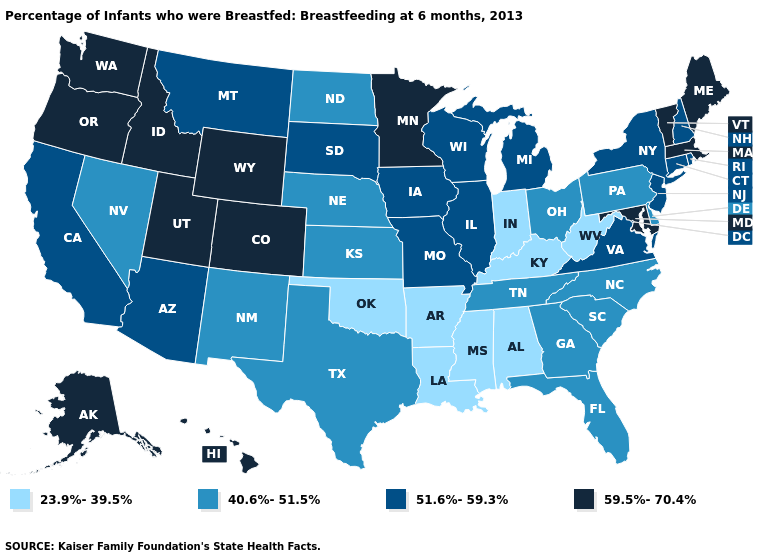What is the value of Mississippi?
Write a very short answer. 23.9%-39.5%. What is the highest value in states that border Tennessee?
Concise answer only. 51.6%-59.3%. What is the value of Alabama?
Answer briefly. 23.9%-39.5%. What is the highest value in the Northeast ?
Keep it brief. 59.5%-70.4%. Is the legend a continuous bar?
Be succinct. No. Does Illinois have the highest value in the USA?
Give a very brief answer. No. What is the highest value in states that border Wyoming?
Quick response, please. 59.5%-70.4%. What is the value of Delaware?
Give a very brief answer. 40.6%-51.5%. Which states have the lowest value in the USA?
Short answer required. Alabama, Arkansas, Indiana, Kentucky, Louisiana, Mississippi, Oklahoma, West Virginia. Name the states that have a value in the range 51.6%-59.3%?
Concise answer only. Arizona, California, Connecticut, Illinois, Iowa, Michigan, Missouri, Montana, New Hampshire, New Jersey, New York, Rhode Island, South Dakota, Virginia, Wisconsin. What is the highest value in the MidWest ?
Short answer required. 59.5%-70.4%. Does Alabama have a lower value than Hawaii?
Keep it brief. Yes. What is the highest value in the USA?
Concise answer only. 59.5%-70.4%. Name the states that have a value in the range 40.6%-51.5%?
Be succinct. Delaware, Florida, Georgia, Kansas, Nebraska, Nevada, New Mexico, North Carolina, North Dakota, Ohio, Pennsylvania, South Carolina, Tennessee, Texas. What is the value of South Dakota?
Keep it brief. 51.6%-59.3%. 